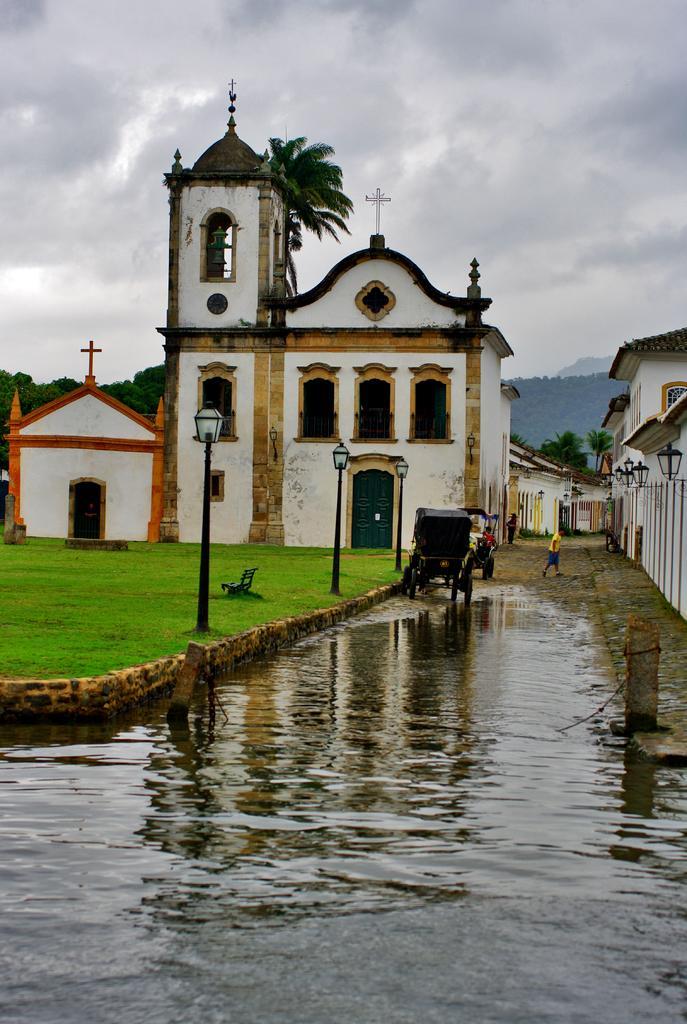Please provide a concise description of this image. In this image I can see water, background I can see few persons walking, light poles, buildings in white and brown, trees in green color and the sky is white color 